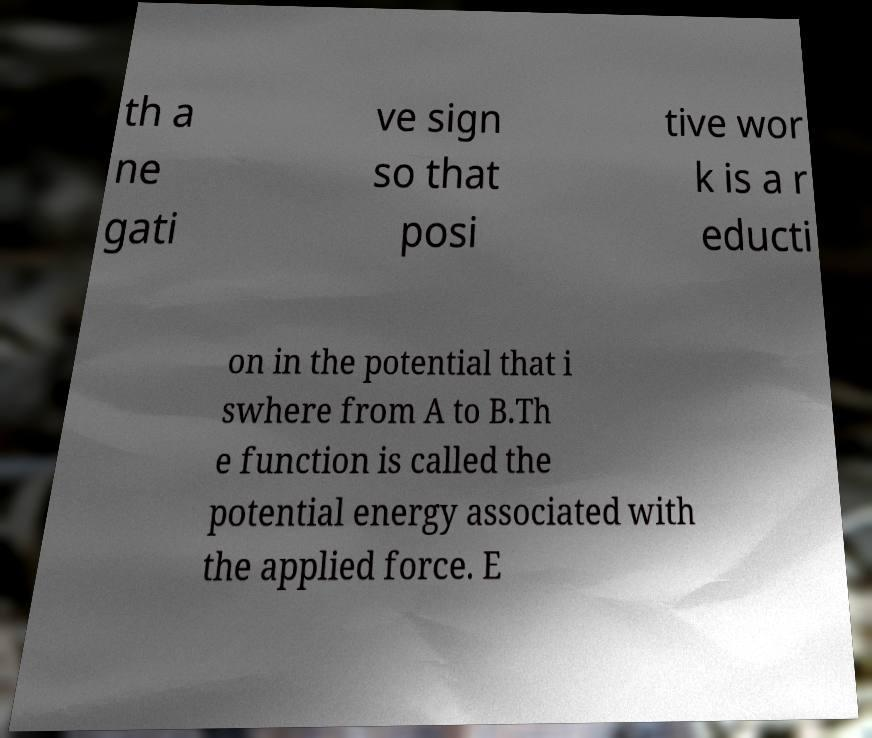Can you read and provide the text displayed in the image?This photo seems to have some interesting text. Can you extract and type it out for me? th a ne gati ve sign so that posi tive wor k is a r educti on in the potential that i swhere from A to B.Th e function is called the potential energy associated with the applied force. E 